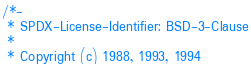Convert code to text. <code><loc_0><loc_0><loc_500><loc_500><_C_>/*-
 * SPDX-License-Identifier: BSD-3-Clause
 *
 * Copyright (c) 1988, 1993, 1994</code> 